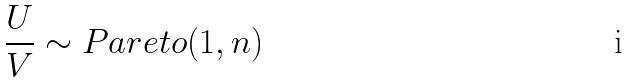Convert formula to latex. <formula><loc_0><loc_0><loc_500><loc_500>\frac { U } { V } \sim P a r e t o ( 1 , n )</formula> 